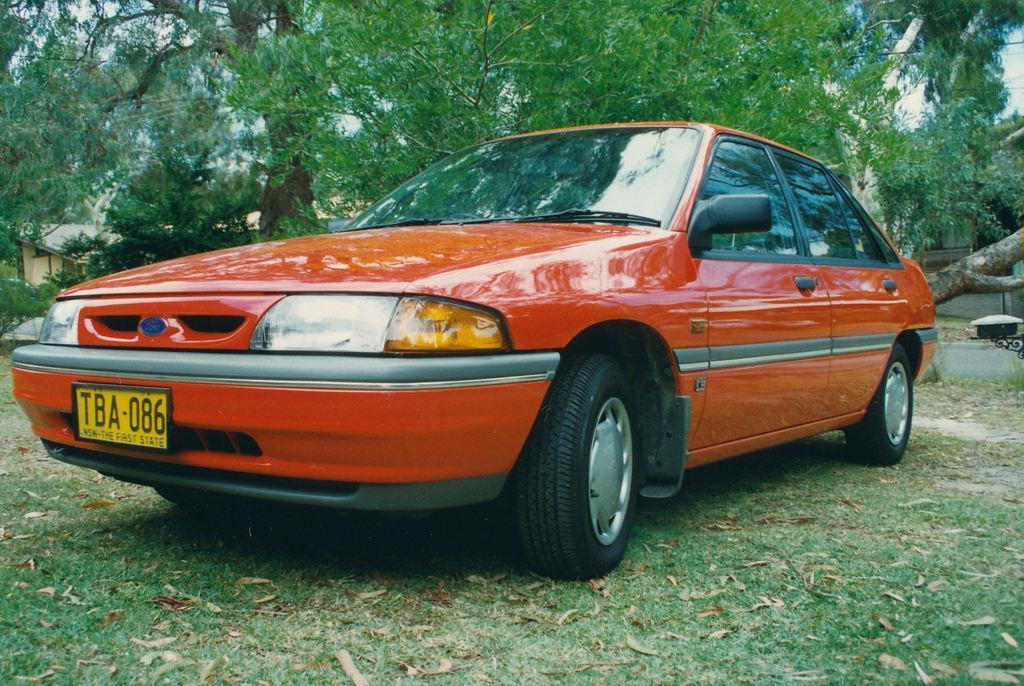Could you give a brief overview of what you see in this image? In the center of the image we can see one car, which is in orange color. In front of the car, we can see one number plate. On the right side of the image, we can see one object. In the background we can see the sky, trees, buildings, grass, dry leaves and a few other objects. 